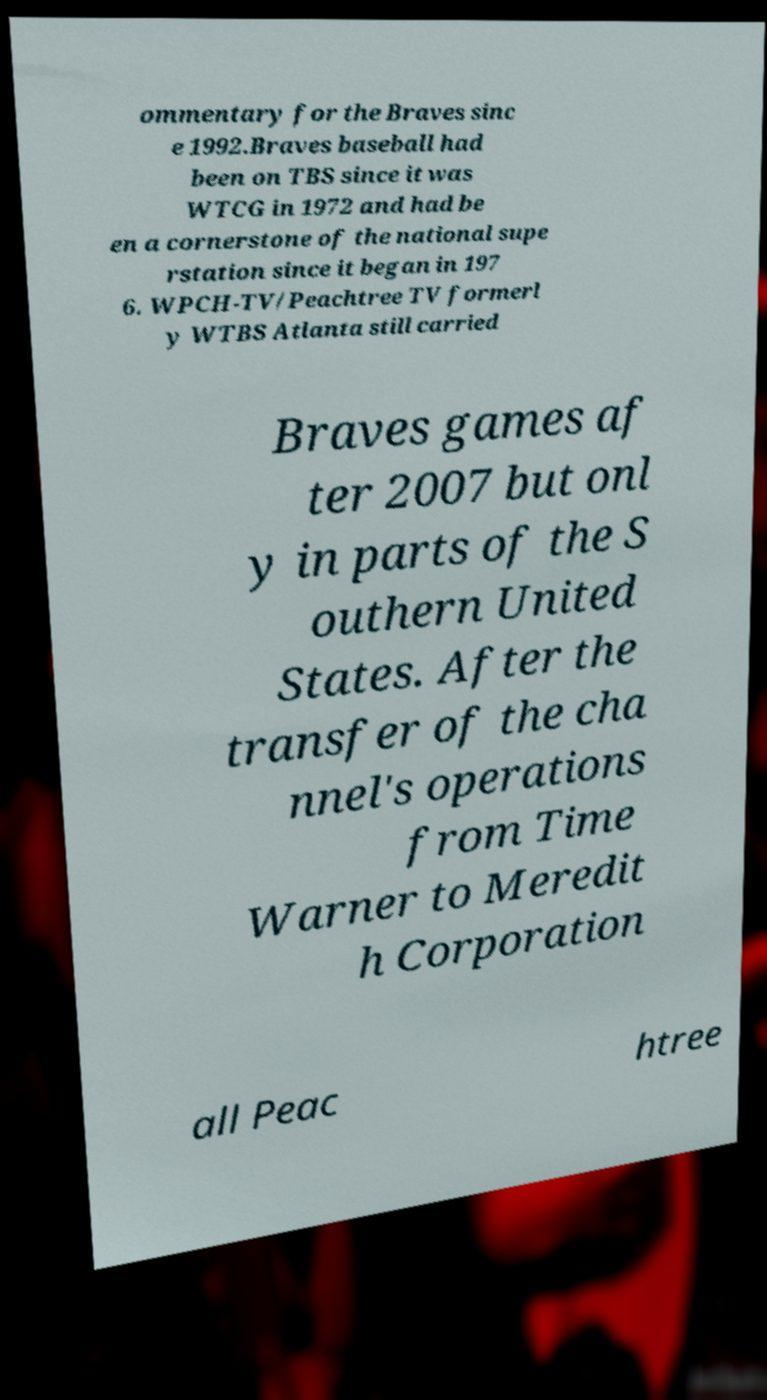Could you extract and type out the text from this image? ommentary for the Braves sinc e 1992.Braves baseball had been on TBS since it was WTCG in 1972 and had be en a cornerstone of the national supe rstation since it began in 197 6. WPCH-TV/Peachtree TV formerl y WTBS Atlanta still carried Braves games af ter 2007 but onl y in parts of the S outhern United States. After the transfer of the cha nnel's operations from Time Warner to Meredit h Corporation all Peac htree 